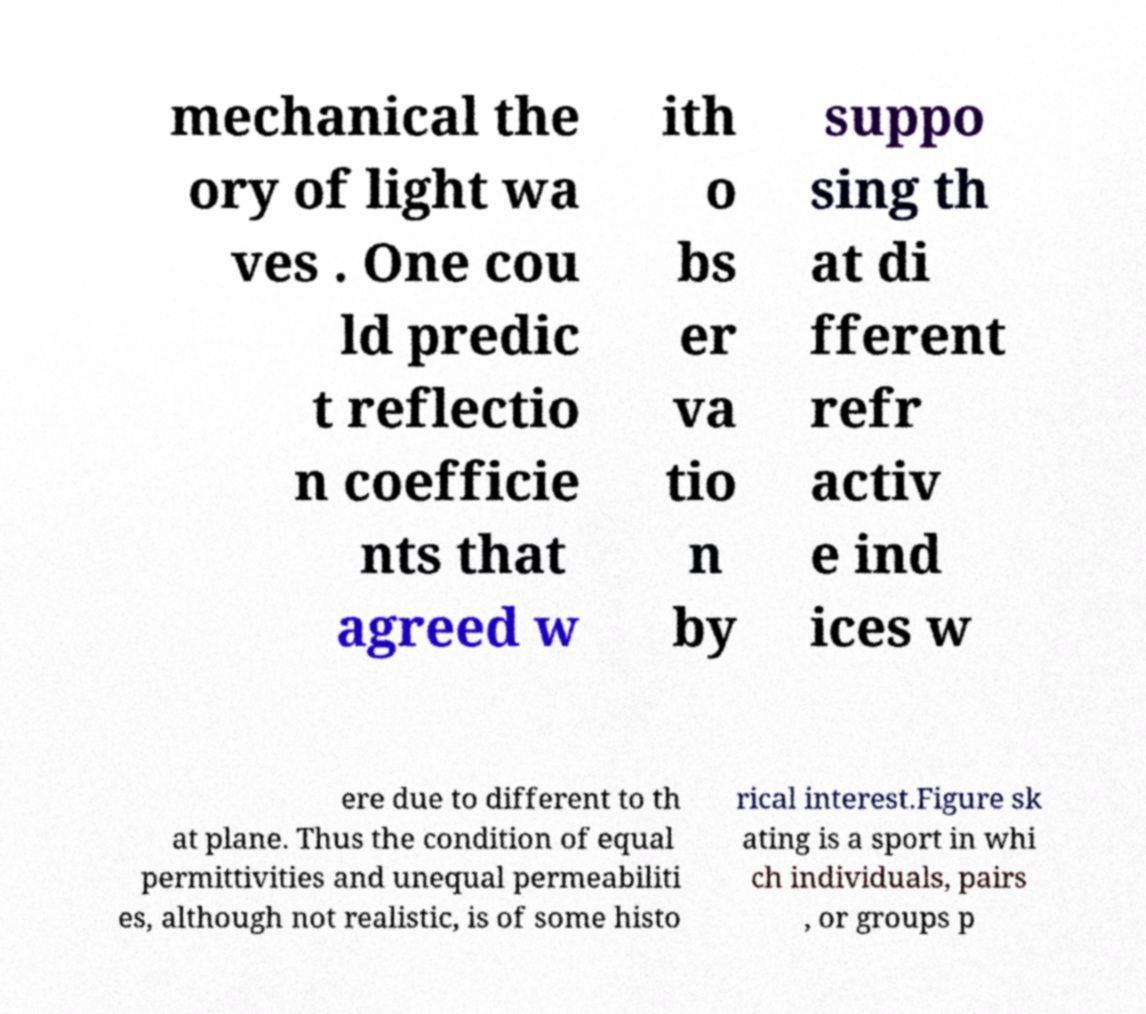Please identify and transcribe the text found in this image. mechanical the ory of light wa ves . One cou ld predic t reflectio n coefficie nts that agreed w ith o bs er va tio n by suppo sing th at di fferent refr activ e ind ices w ere due to different to th at plane. Thus the condition of equal permittivities and unequal permeabiliti es, although not realistic, is of some histo rical interest.Figure sk ating is a sport in whi ch individuals, pairs , or groups p 